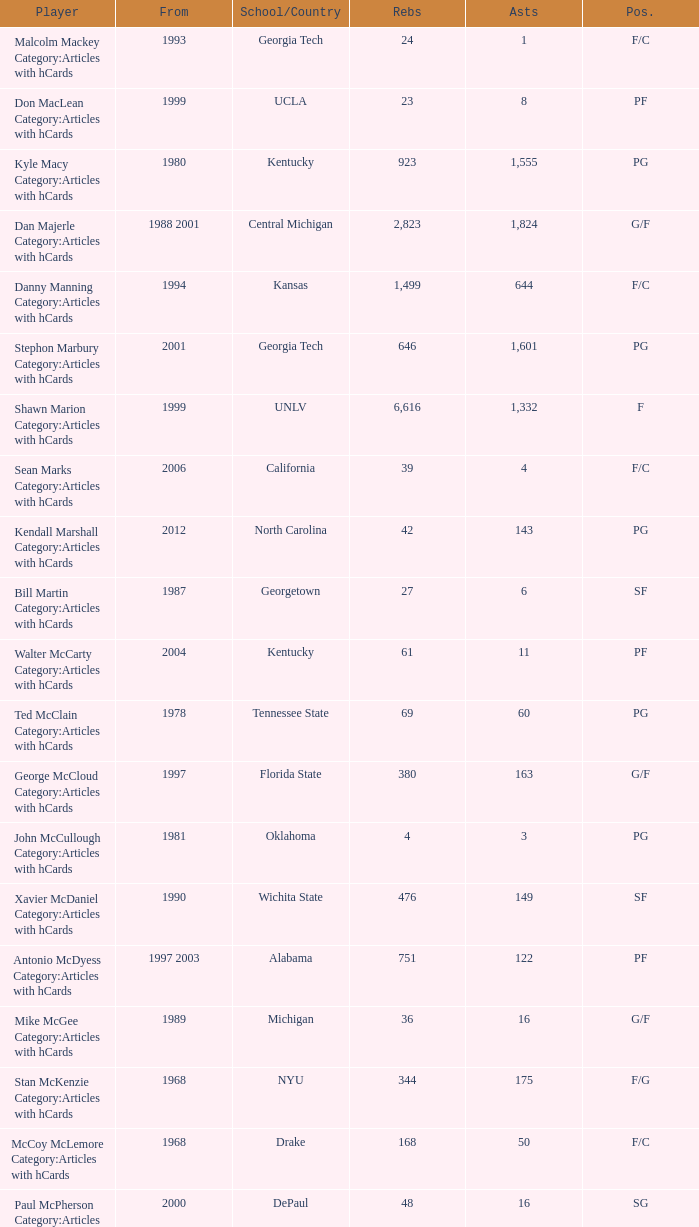Who has the high assists in 2000? 16.0. 